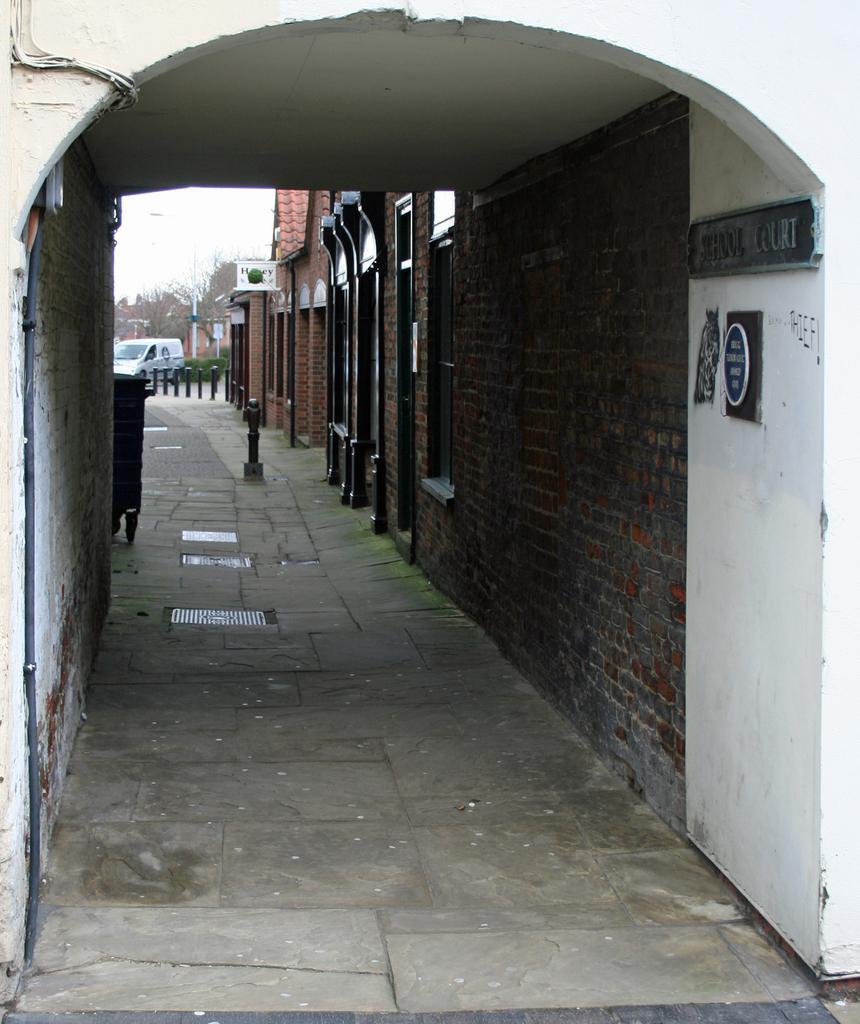Describe this image in one or two sentences. In this image we can see a road. On the road there are drainage grills and a pole. On the right side there is a brick wall. Also there is a board with something written. In the back there are poles, trees and a vehicle. 